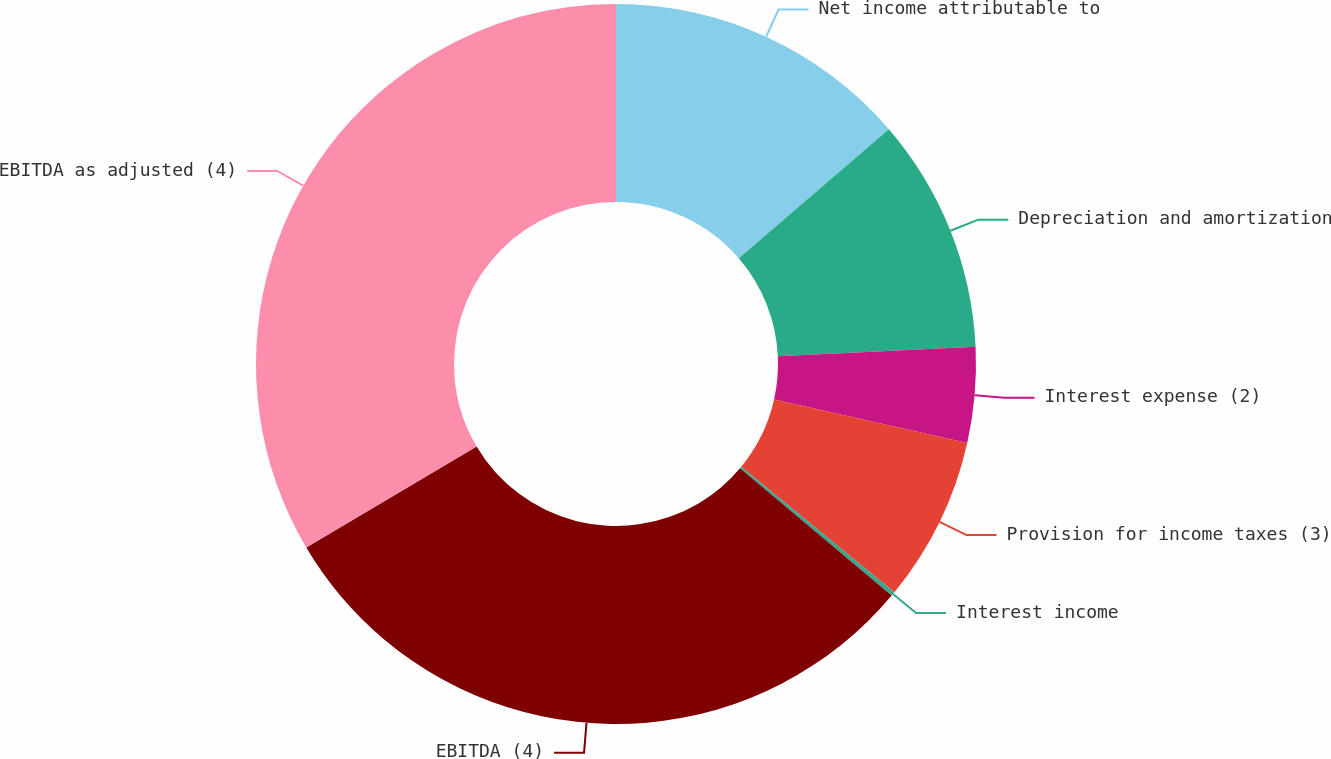<chart> <loc_0><loc_0><loc_500><loc_500><pie_chart><fcel>Net income attributable to<fcel>Depreciation and amortization<fcel>Interest expense (2)<fcel>Provision for income taxes (3)<fcel>Interest income<fcel>EBITDA (4)<fcel>EBITDA as adjusted (4)<nl><fcel>13.69%<fcel>10.55%<fcel>4.28%<fcel>7.41%<fcel>0.19%<fcel>30.37%<fcel>33.51%<nl></chart> 